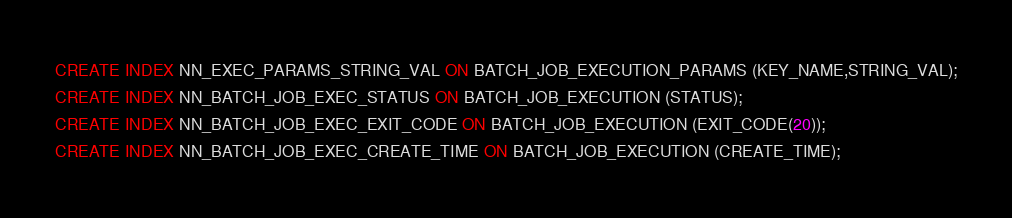<code> <loc_0><loc_0><loc_500><loc_500><_SQL_>CREATE INDEX NN_EXEC_PARAMS_STRING_VAL ON BATCH_JOB_EXECUTION_PARAMS (KEY_NAME,STRING_VAL);
CREATE INDEX NN_BATCH_JOB_EXEC_STATUS ON BATCH_JOB_EXECUTION (STATUS);
CREATE INDEX NN_BATCH_JOB_EXEC_EXIT_CODE ON BATCH_JOB_EXECUTION (EXIT_CODE(20));
CREATE INDEX NN_BATCH_JOB_EXEC_CREATE_TIME ON BATCH_JOB_EXECUTION (CREATE_TIME);
</code> 